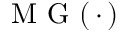<formula> <loc_0><loc_0><loc_500><loc_500>M G ( \, \cdot \, )</formula> 